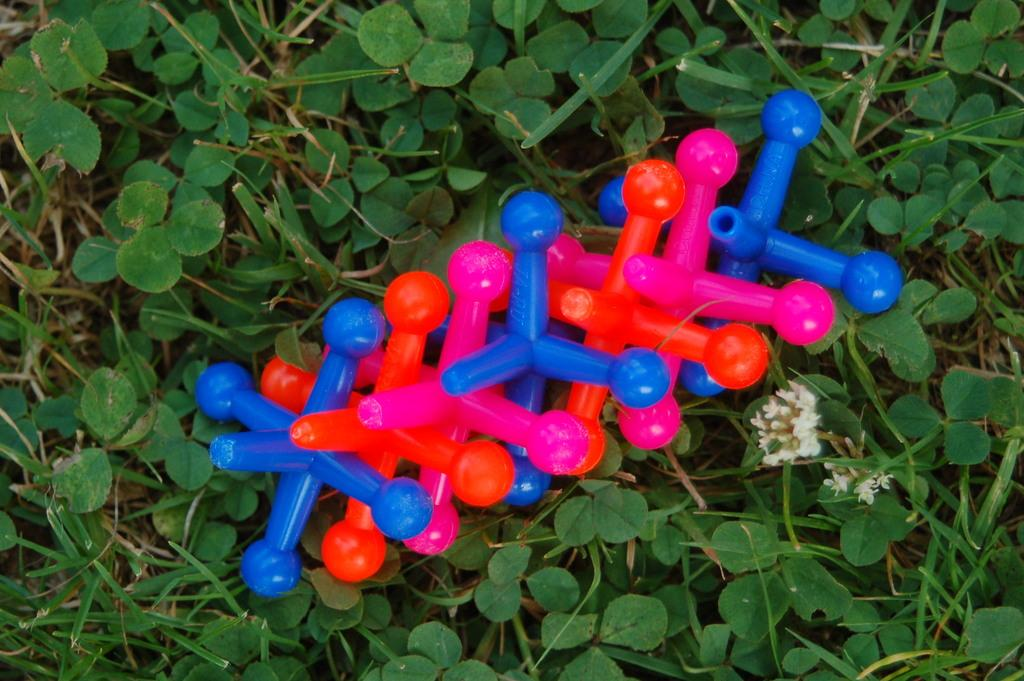What type of vegetation is visible in the image? There is grass and plants visible in the image. What is placed on the plants in the image? There are objects placed on the plants in the image. What type of books can be seen in the library in the image? There is no library present in the image, as it features grass, plants, and objects placed on the plants. What effect does the crow have on the plants in the image? There is no crow present in the image, so it cannot have any effect on the plants. 